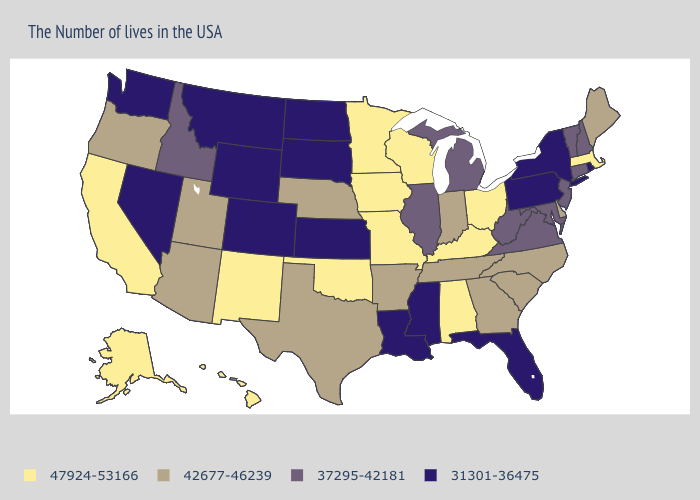What is the value of Arkansas?
Short answer required. 42677-46239. What is the value of Maryland?
Write a very short answer. 37295-42181. What is the value of North Dakota?
Quick response, please. 31301-36475. Name the states that have a value in the range 37295-42181?
Quick response, please. New Hampshire, Vermont, Connecticut, New Jersey, Maryland, Virginia, West Virginia, Michigan, Illinois, Idaho. What is the lowest value in the USA?
Write a very short answer. 31301-36475. Among the states that border New Mexico , which have the lowest value?
Write a very short answer. Colorado. What is the value of Nevada?
Write a very short answer. 31301-36475. What is the value of Nevada?
Give a very brief answer. 31301-36475. Which states have the lowest value in the USA?
Keep it brief. Rhode Island, New York, Pennsylvania, Florida, Mississippi, Louisiana, Kansas, South Dakota, North Dakota, Wyoming, Colorado, Montana, Nevada, Washington. Among the states that border Missouri , does Kansas have the lowest value?
Give a very brief answer. Yes. What is the value of Idaho?
Short answer required. 37295-42181. Does the first symbol in the legend represent the smallest category?
Write a very short answer. No. What is the value of Alaska?
Be succinct. 47924-53166. How many symbols are there in the legend?
Quick response, please. 4. Does South Carolina have the highest value in the South?
Be succinct. No. 